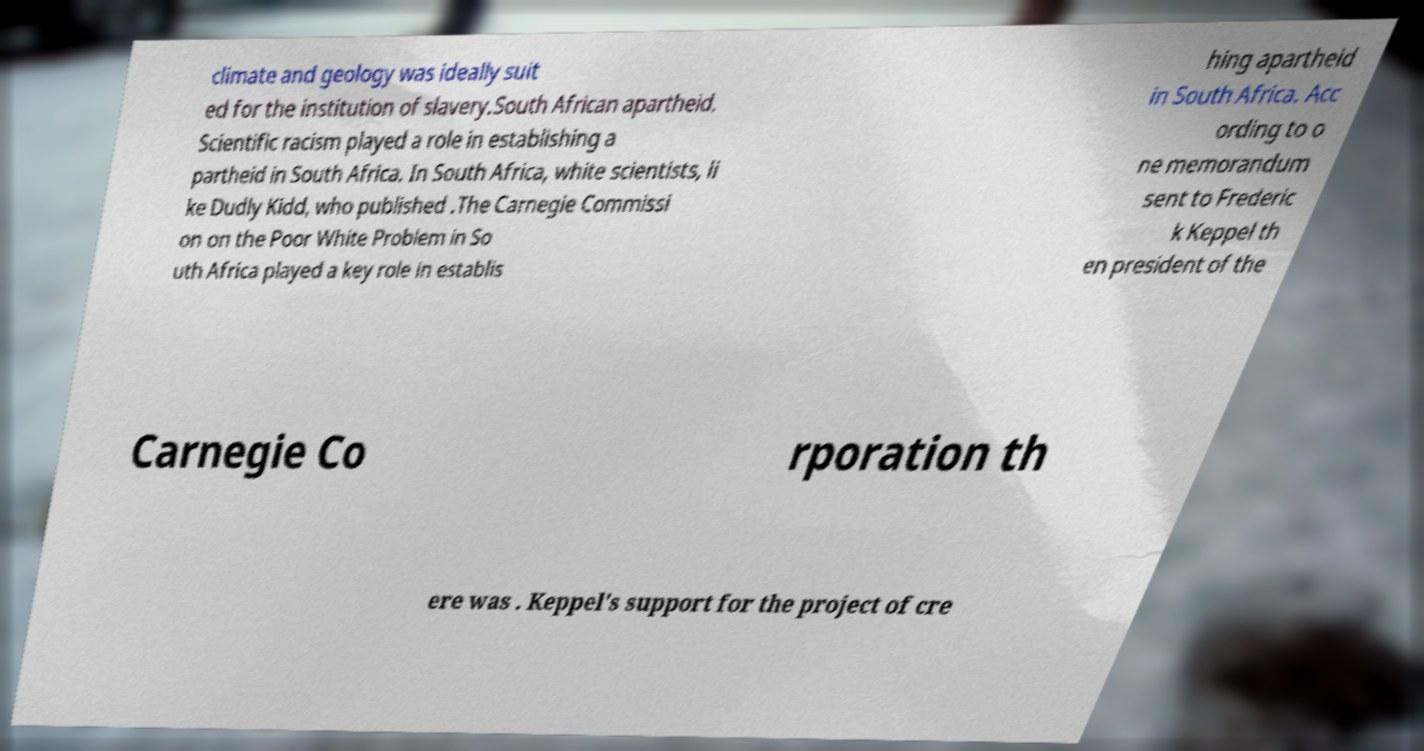Could you extract and type out the text from this image? climate and geology was ideally suit ed for the institution of slavery.South African apartheid. Scientific racism played a role in establishing a partheid in South Africa. In South Africa, white scientists, li ke Dudly Kidd, who published .The Carnegie Commissi on on the Poor White Problem in So uth Africa played a key role in establis hing apartheid in South Africa. Acc ording to o ne memorandum sent to Frederic k Keppel th en president of the Carnegie Co rporation th ere was . Keppel's support for the project of cre 